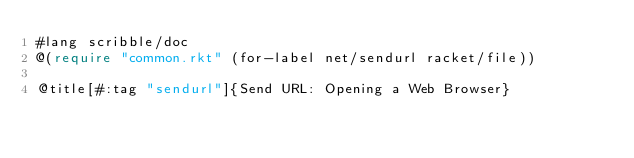<code> <loc_0><loc_0><loc_500><loc_500><_Racket_>#lang scribble/doc
@(require "common.rkt" (for-label net/sendurl racket/file))

@title[#:tag "sendurl"]{Send URL: Opening a Web Browser}
</code> 